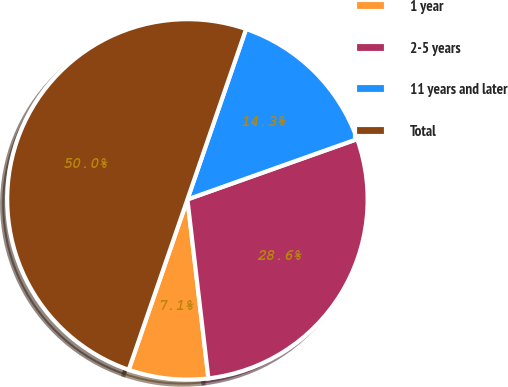Convert chart to OTSL. <chart><loc_0><loc_0><loc_500><loc_500><pie_chart><fcel>1 year<fcel>2-5 years<fcel>11 years and later<fcel>Total<nl><fcel>7.14%<fcel>28.57%<fcel>14.29%<fcel>50.0%<nl></chart> 